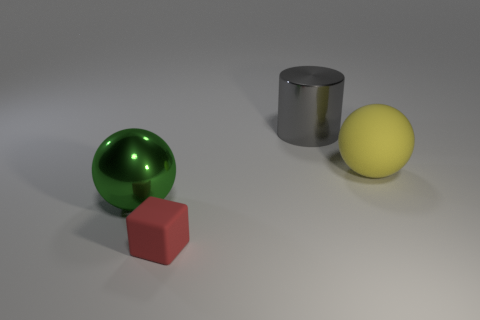If we were to illuminate this scene with a bright light from the right, what shadows would each object cast? With a bright light source to the right, each object would cast a shadow to the left. The sphere would cast a circular shadow, the cube would cast a square-shaped shadow, and the cylinder would cast a shadow with an elliptical shape due to its roundness. 